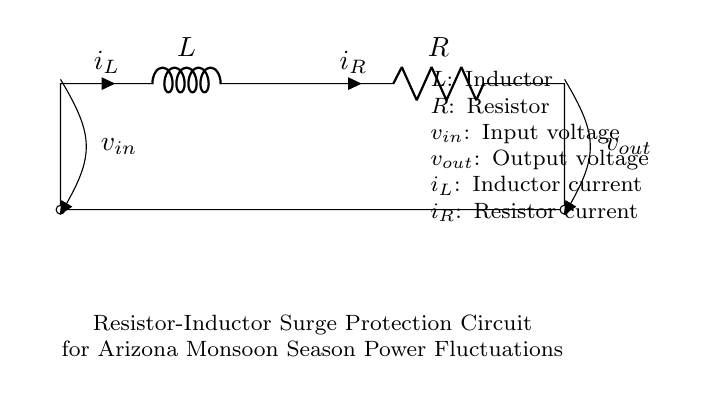What components are in this circuit? The circuit diagram shows two main components: an inductor (L) and a resistor (R). These are the only components represented alongside the input and output voltages.
Answer: inductor, resistor What is the input voltage labeled in the circuit? The input voltage is labeled as v sub in, which indicates the voltage supplied to the circuit. It's positioned above the left side of the circuit.
Answer: v sub in What is the purpose of the resistor and inductor in this circuit? The purpose of the resistor is to limit current flow and dissipate energy, while the inductor is used to store energy as a magnetic field. Together, they provide surge protection by managing power fluctuations.
Answer: surge protection Which current flows through the inductor? The current flowing through the inductor is indicated as i sub L, which is marked on the circuit diagram. This represents the current that builds up in the inductor due to voltage changes.
Answer: i sub L How does the output voltage relate to the input voltage in surge protection? The output voltage (v sub out) is affected by how the inductor and resistor manage the input voltage during surges. The inductor helps slow down rapid changes, reducing spikes in v sub out.
Answer: regulated What effect does the inductor have on current during a power surge? The inductor resists changes in current due to its property of inductance, which helps prevent sudden spikes or drops in current during a power surge, thereby protecting appliances.
Answer: limits current change What function does the resistor serve in the circuit dynamics? The resistor dissipates energy and controls current flow through the circuit, which helps to stabilize the output voltage during power fluctuations, thus protecting devices connected to it.
Answer: controls current flow 